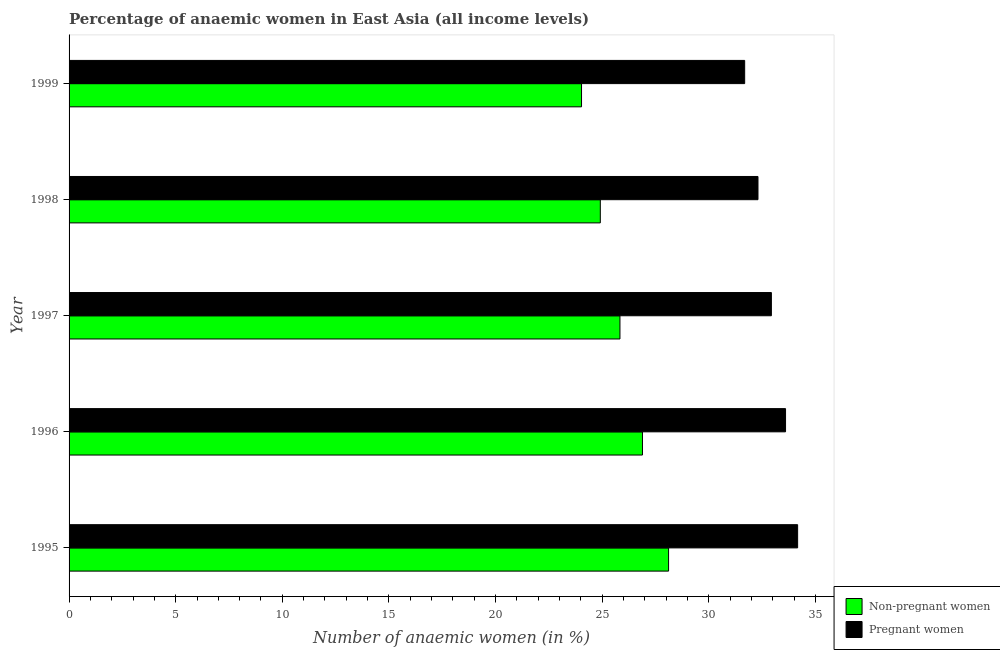How many bars are there on the 1st tick from the bottom?
Provide a short and direct response. 2. In how many cases, is the number of bars for a given year not equal to the number of legend labels?
Offer a terse response. 0. What is the percentage of non-pregnant anaemic women in 1997?
Offer a very short reply. 25.84. Across all years, what is the maximum percentage of pregnant anaemic women?
Keep it short and to the point. 34.17. Across all years, what is the minimum percentage of non-pregnant anaemic women?
Provide a succinct answer. 24.03. In which year was the percentage of pregnant anaemic women maximum?
Your response must be concise. 1995. In which year was the percentage of non-pregnant anaemic women minimum?
Make the answer very short. 1999. What is the total percentage of non-pregnant anaemic women in the graph?
Offer a very short reply. 129.8. What is the difference between the percentage of pregnant anaemic women in 1998 and that in 1999?
Your answer should be compact. 0.62. What is the difference between the percentage of pregnant anaemic women in 1997 and the percentage of non-pregnant anaemic women in 1996?
Your answer should be compact. 6.05. What is the average percentage of pregnant anaemic women per year?
Your answer should be very brief. 32.94. In the year 1995, what is the difference between the percentage of pregnant anaemic women and percentage of non-pregnant anaemic women?
Your answer should be very brief. 6.05. In how many years, is the percentage of pregnant anaemic women greater than 2 %?
Keep it short and to the point. 5. What is the ratio of the percentage of non-pregnant anaemic women in 1995 to that in 1999?
Keep it short and to the point. 1.17. Is the difference between the percentage of pregnant anaemic women in 1997 and 1998 greater than the difference between the percentage of non-pregnant anaemic women in 1997 and 1998?
Provide a succinct answer. No. What is the difference between the highest and the second highest percentage of non-pregnant anaemic women?
Offer a very short reply. 1.22. What is the difference between the highest and the lowest percentage of pregnant anaemic women?
Offer a very short reply. 2.48. What does the 1st bar from the top in 1997 represents?
Your response must be concise. Pregnant women. What does the 1st bar from the bottom in 1997 represents?
Make the answer very short. Non-pregnant women. How many bars are there?
Your answer should be very brief. 10. How many years are there in the graph?
Your answer should be very brief. 5. Does the graph contain any zero values?
Ensure brevity in your answer.  No. Where does the legend appear in the graph?
Ensure brevity in your answer.  Bottom right. How many legend labels are there?
Provide a succinct answer. 2. What is the title of the graph?
Ensure brevity in your answer.  Percentage of anaemic women in East Asia (all income levels). Does "Short-term debt" appear as one of the legend labels in the graph?
Offer a very short reply. No. What is the label or title of the X-axis?
Ensure brevity in your answer.  Number of anaemic women (in %). What is the label or title of the Y-axis?
Make the answer very short. Year. What is the Number of anaemic women (in %) in Non-pregnant women in 1995?
Keep it short and to the point. 28.12. What is the Number of anaemic women (in %) in Pregnant women in 1995?
Provide a succinct answer. 34.17. What is the Number of anaemic women (in %) in Non-pregnant women in 1996?
Your response must be concise. 26.89. What is the Number of anaemic women (in %) in Pregnant women in 1996?
Your response must be concise. 33.6. What is the Number of anaemic women (in %) in Non-pregnant women in 1997?
Your answer should be compact. 25.84. What is the Number of anaemic women (in %) in Pregnant women in 1997?
Your answer should be compact. 32.94. What is the Number of anaemic women (in %) in Non-pregnant women in 1998?
Make the answer very short. 24.92. What is the Number of anaemic women (in %) in Pregnant women in 1998?
Provide a succinct answer. 32.31. What is the Number of anaemic women (in %) in Non-pregnant women in 1999?
Offer a very short reply. 24.03. What is the Number of anaemic women (in %) of Pregnant women in 1999?
Your answer should be very brief. 31.69. Across all years, what is the maximum Number of anaemic women (in %) of Non-pregnant women?
Ensure brevity in your answer.  28.12. Across all years, what is the maximum Number of anaemic women (in %) of Pregnant women?
Provide a succinct answer. 34.17. Across all years, what is the minimum Number of anaemic women (in %) in Non-pregnant women?
Your answer should be very brief. 24.03. Across all years, what is the minimum Number of anaemic women (in %) of Pregnant women?
Give a very brief answer. 31.69. What is the total Number of anaemic women (in %) of Non-pregnant women in the graph?
Offer a terse response. 129.8. What is the total Number of anaemic women (in %) in Pregnant women in the graph?
Provide a succinct answer. 164.71. What is the difference between the Number of anaemic women (in %) of Non-pregnant women in 1995 and that in 1996?
Give a very brief answer. 1.22. What is the difference between the Number of anaemic women (in %) in Pregnant women in 1995 and that in 1996?
Make the answer very short. 0.57. What is the difference between the Number of anaemic women (in %) of Non-pregnant women in 1995 and that in 1997?
Provide a succinct answer. 2.28. What is the difference between the Number of anaemic women (in %) in Pregnant women in 1995 and that in 1997?
Your answer should be very brief. 1.23. What is the difference between the Number of anaemic women (in %) in Non-pregnant women in 1995 and that in 1998?
Offer a terse response. 3.2. What is the difference between the Number of anaemic women (in %) of Pregnant women in 1995 and that in 1998?
Keep it short and to the point. 1.86. What is the difference between the Number of anaemic women (in %) in Non-pregnant women in 1995 and that in 1999?
Provide a short and direct response. 4.08. What is the difference between the Number of anaemic women (in %) of Pregnant women in 1995 and that in 1999?
Keep it short and to the point. 2.48. What is the difference between the Number of anaemic women (in %) in Non-pregnant women in 1996 and that in 1997?
Your answer should be compact. 1.06. What is the difference between the Number of anaemic women (in %) in Pregnant women in 1996 and that in 1997?
Provide a short and direct response. 0.66. What is the difference between the Number of anaemic women (in %) in Non-pregnant women in 1996 and that in 1998?
Keep it short and to the point. 1.98. What is the difference between the Number of anaemic women (in %) in Pregnant women in 1996 and that in 1998?
Ensure brevity in your answer.  1.29. What is the difference between the Number of anaemic women (in %) in Non-pregnant women in 1996 and that in 1999?
Offer a very short reply. 2.86. What is the difference between the Number of anaemic women (in %) of Pregnant women in 1996 and that in 1999?
Give a very brief answer. 1.92. What is the difference between the Number of anaemic women (in %) in Non-pregnant women in 1997 and that in 1998?
Make the answer very short. 0.92. What is the difference between the Number of anaemic women (in %) in Pregnant women in 1997 and that in 1998?
Offer a terse response. 0.63. What is the difference between the Number of anaemic women (in %) of Non-pregnant women in 1997 and that in 1999?
Offer a very short reply. 1.8. What is the difference between the Number of anaemic women (in %) in Pregnant women in 1997 and that in 1999?
Your response must be concise. 1.25. What is the difference between the Number of anaemic women (in %) of Non-pregnant women in 1998 and that in 1999?
Provide a succinct answer. 0.88. What is the difference between the Number of anaemic women (in %) in Pregnant women in 1998 and that in 1999?
Provide a short and direct response. 0.62. What is the difference between the Number of anaemic women (in %) of Non-pregnant women in 1995 and the Number of anaemic women (in %) of Pregnant women in 1996?
Your answer should be very brief. -5.49. What is the difference between the Number of anaemic women (in %) of Non-pregnant women in 1995 and the Number of anaemic women (in %) of Pregnant women in 1997?
Your answer should be compact. -4.82. What is the difference between the Number of anaemic women (in %) of Non-pregnant women in 1995 and the Number of anaemic women (in %) of Pregnant women in 1998?
Ensure brevity in your answer.  -4.19. What is the difference between the Number of anaemic women (in %) in Non-pregnant women in 1995 and the Number of anaemic women (in %) in Pregnant women in 1999?
Provide a succinct answer. -3.57. What is the difference between the Number of anaemic women (in %) of Non-pregnant women in 1996 and the Number of anaemic women (in %) of Pregnant women in 1997?
Provide a short and direct response. -6.05. What is the difference between the Number of anaemic women (in %) in Non-pregnant women in 1996 and the Number of anaemic women (in %) in Pregnant women in 1998?
Offer a very short reply. -5.42. What is the difference between the Number of anaemic women (in %) in Non-pregnant women in 1996 and the Number of anaemic women (in %) in Pregnant women in 1999?
Keep it short and to the point. -4.79. What is the difference between the Number of anaemic women (in %) in Non-pregnant women in 1997 and the Number of anaemic women (in %) in Pregnant women in 1998?
Give a very brief answer. -6.47. What is the difference between the Number of anaemic women (in %) of Non-pregnant women in 1997 and the Number of anaemic women (in %) of Pregnant women in 1999?
Make the answer very short. -5.85. What is the difference between the Number of anaemic women (in %) in Non-pregnant women in 1998 and the Number of anaemic women (in %) in Pregnant women in 1999?
Ensure brevity in your answer.  -6.77. What is the average Number of anaemic women (in %) of Non-pregnant women per year?
Provide a succinct answer. 25.96. What is the average Number of anaemic women (in %) in Pregnant women per year?
Provide a short and direct response. 32.94. In the year 1995, what is the difference between the Number of anaemic women (in %) in Non-pregnant women and Number of anaemic women (in %) in Pregnant women?
Keep it short and to the point. -6.05. In the year 1996, what is the difference between the Number of anaemic women (in %) of Non-pregnant women and Number of anaemic women (in %) of Pregnant women?
Ensure brevity in your answer.  -6.71. In the year 1997, what is the difference between the Number of anaemic women (in %) in Non-pregnant women and Number of anaemic women (in %) in Pregnant women?
Offer a very short reply. -7.1. In the year 1998, what is the difference between the Number of anaemic women (in %) in Non-pregnant women and Number of anaemic women (in %) in Pregnant women?
Offer a terse response. -7.39. In the year 1999, what is the difference between the Number of anaemic women (in %) of Non-pregnant women and Number of anaemic women (in %) of Pregnant women?
Provide a short and direct response. -7.65. What is the ratio of the Number of anaemic women (in %) in Non-pregnant women in 1995 to that in 1996?
Offer a terse response. 1.05. What is the ratio of the Number of anaemic women (in %) of Pregnant women in 1995 to that in 1996?
Offer a very short reply. 1.02. What is the ratio of the Number of anaemic women (in %) in Non-pregnant women in 1995 to that in 1997?
Your response must be concise. 1.09. What is the ratio of the Number of anaemic women (in %) in Pregnant women in 1995 to that in 1997?
Offer a terse response. 1.04. What is the ratio of the Number of anaemic women (in %) in Non-pregnant women in 1995 to that in 1998?
Your answer should be compact. 1.13. What is the ratio of the Number of anaemic women (in %) of Pregnant women in 1995 to that in 1998?
Give a very brief answer. 1.06. What is the ratio of the Number of anaemic women (in %) in Non-pregnant women in 1995 to that in 1999?
Offer a terse response. 1.17. What is the ratio of the Number of anaemic women (in %) in Pregnant women in 1995 to that in 1999?
Give a very brief answer. 1.08. What is the ratio of the Number of anaemic women (in %) of Non-pregnant women in 1996 to that in 1997?
Give a very brief answer. 1.04. What is the ratio of the Number of anaemic women (in %) in Pregnant women in 1996 to that in 1997?
Ensure brevity in your answer.  1.02. What is the ratio of the Number of anaemic women (in %) of Non-pregnant women in 1996 to that in 1998?
Your answer should be compact. 1.08. What is the ratio of the Number of anaemic women (in %) of Pregnant women in 1996 to that in 1998?
Your answer should be compact. 1.04. What is the ratio of the Number of anaemic women (in %) of Non-pregnant women in 1996 to that in 1999?
Keep it short and to the point. 1.12. What is the ratio of the Number of anaemic women (in %) in Pregnant women in 1996 to that in 1999?
Your answer should be very brief. 1.06. What is the ratio of the Number of anaemic women (in %) of Non-pregnant women in 1997 to that in 1998?
Ensure brevity in your answer.  1.04. What is the ratio of the Number of anaemic women (in %) of Pregnant women in 1997 to that in 1998?
Make the answer very short. 1.02. What is the ratio of the Number of anaemic women (in %) of Non-pregnant women in 1997 to that in 1999?
Your answer should be very brief. 1.07. What is the ratio of the Number of anaemic women (in %) in Pregnant women in 1997 to that in 1999?
Give a very brief answer. 1.04. What is the ratio of the Number of anaemic women (in %) of Non-pregnant women in 1998 to that in 1999?
Make the answer very short. 1.04. What is the ratio of the Number of anaemic women (in %) of Pregnant women in 1998 to that in 1999?
Provide a succinct answer. 1.02. What is the difference between the highest and the second highest Number of anaemic women (in %) of Non-pregnant women?
Your answer should be very brief. 1.22. What is the difference between the highest and the second highest Number of anaemic women (in %) of Pregnant women?
Give a very brief answer. 0.57. What is the difference between the highest and the lowest Number of anaemic women (in %) in Non-pregnant women?
Give a very brief answer. 4.08. What is the difference between the highest and the lowest Number of anaemic women (in %) of Pregnant women?
Offer a terse response. 2.48. 